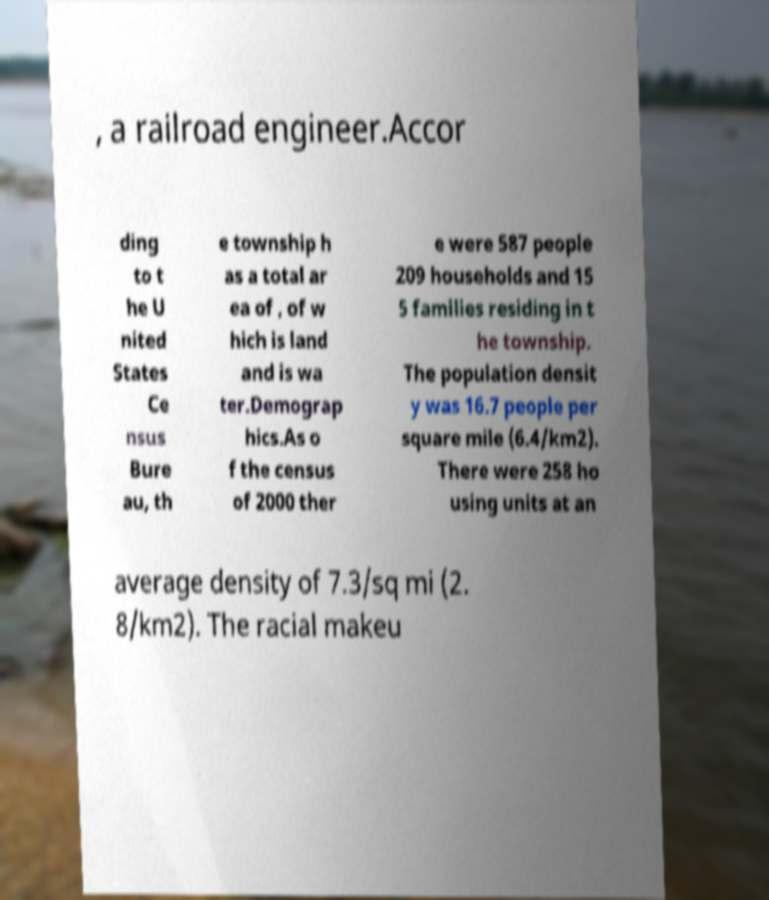For documentation purposes, I need the text within this image transcribed. Could you provide that? , a railroad engineer.Accor ding to t he U nited States Ce nsus Bure au, th e township h as a total ar ea of , of w hich is land and is wa ter.Demograp hics.As o f the census of 2000 ther e were 587 people 209 households and 15 5 families residing in t he township. The population densit y was 16.7 people per square mile (6.4/km2). There were 258 ho using units at an average density of 7.3/sq mi (2. 8/km2). The racial makeu 